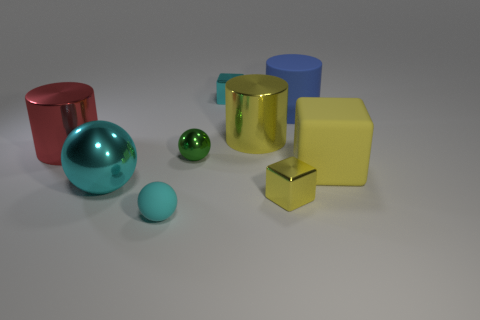There is another cube that is the same color as the large cube; what material is it?
Provide a succinct answer. Metal. What number of objects are either balls or tiny cyan metallic blocks?
Offer a terse response. 4. There is another yellow object that is the same shape as the tiny yellow metallic object; what is its size?
Your response must be concise. Large. How many other things are there of the same color as the rubber cylinder?
Ensure brevity in your answer.  0. What number of cylinders are either green objects or small objects?
Provide a short and direct response. 0. What is the color of the matte cube that is behind the small block to the right of the large yellow metal object?
Provide a succinct answer. Yellow. What is the shape of the small rubber object?
Your answer should be compact. Sphere. There is a metallic ball behind the yellow matte thing; is its size the same as the small cyan shiny thing?
Keep it short and to the point. Yes. Are there any small cyan things made of the same material as the big block?
Your response must be concise. Yes. What number of objects are either metallic blocks behind the big red object or small green balls?
Ensure brevity in your answer.  2. 